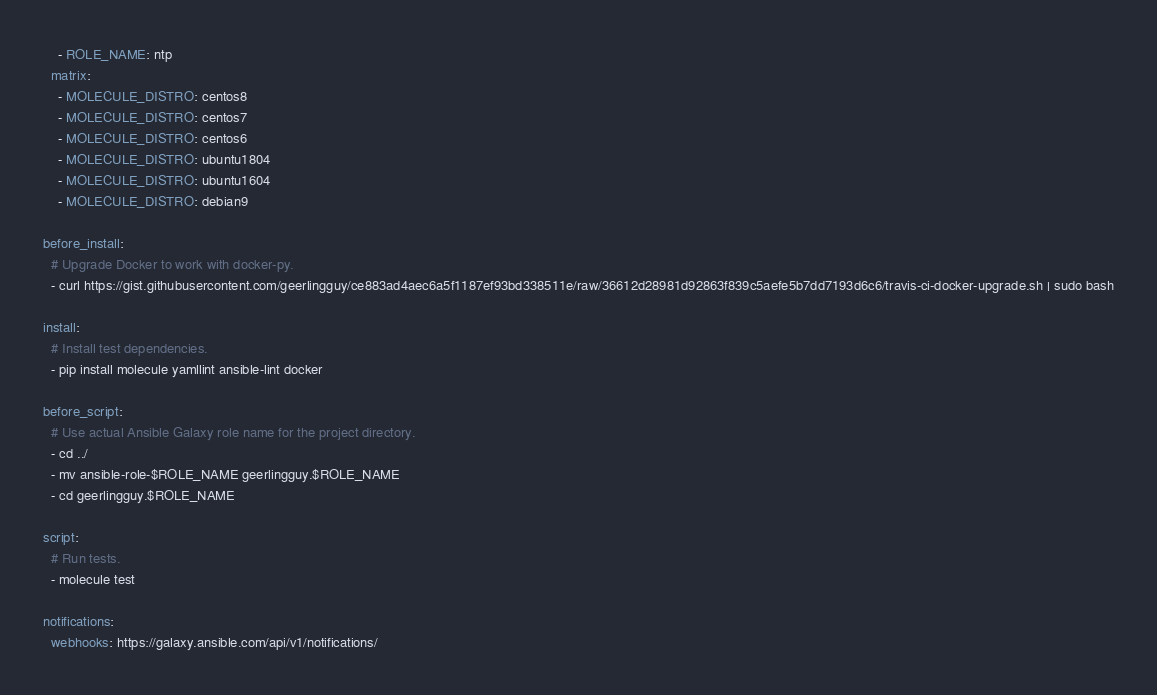Convert code to text. <code><loc_0><loc_0><loc_500><loc_500><_YAML_>    - ROLE_NAME: ntp
  matrix:
    - MOLECULE_DISTRO: centos8
    - MOLECULE_DISTRO: centos7
    - MOLECULE_DISTRO: centos6
    - MOLECULE_DISTRO: ubuntu1804
    - MOLECULE_DISTRO: ubuntu1604
    - MOLECULE_DISTRO: debian9

before_install:
  # Upgrade Docker to work with docker-py.
  - curl https://gist.githubusercontent.com/geerlingguy/ce883ad4aec6a5f1187ef93bd338511e/raw/36612d28981d92863f839c5aefe5b7dd7193d6c6/travis-ci-docker-upgrade.sh | sudo bash

install:
  # Install test dependencies.
  - pip install molecule yamllint ansible-lint docker

before_script:
  # Use actual Ansible Galaxy role name for the project directory.
  - cd ../
  - mv ansible-role-$ROLE_NAME geerlingguy.$ROLE_NAME
  - cd geerlingguy.$ROLE_NAME

script:
  # Run tests.
  - molecule test

notifications:
  webhooks: https://galaxy.ansible.com/api/v1/notifications/
</code> 